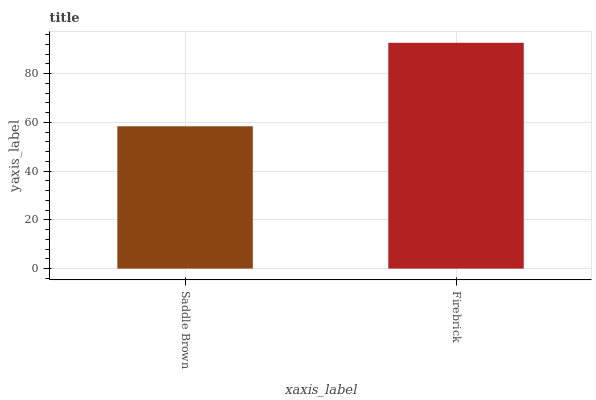Is Saddle Brown the minimum?
Answer yes or no. Yes. Is Firebrick the maximum?
Answer yes or no. Yes. Is Firebrick the minimum?
Answer yes or no. No. Is Firebrick greater than Saddle Brown?
Answer yes or no. Yes. Is Saddle Brown less than Firebrick?
Answer yes or no. Yes. Is Saddle Brown greater than Firebrick?
Answer yes or no. No. Is Firebrick less than Saddle Brown?
Answer yes or no. No. Is Firebrick the high median?
Answer yes or no. Yes. Is Saddle Brown the low median?
Answer yes or no. Yes. Is Saddle Brown the high median?
Answer yes or no. No. Is Firebrick the low median?
Answer yes or no. No. 